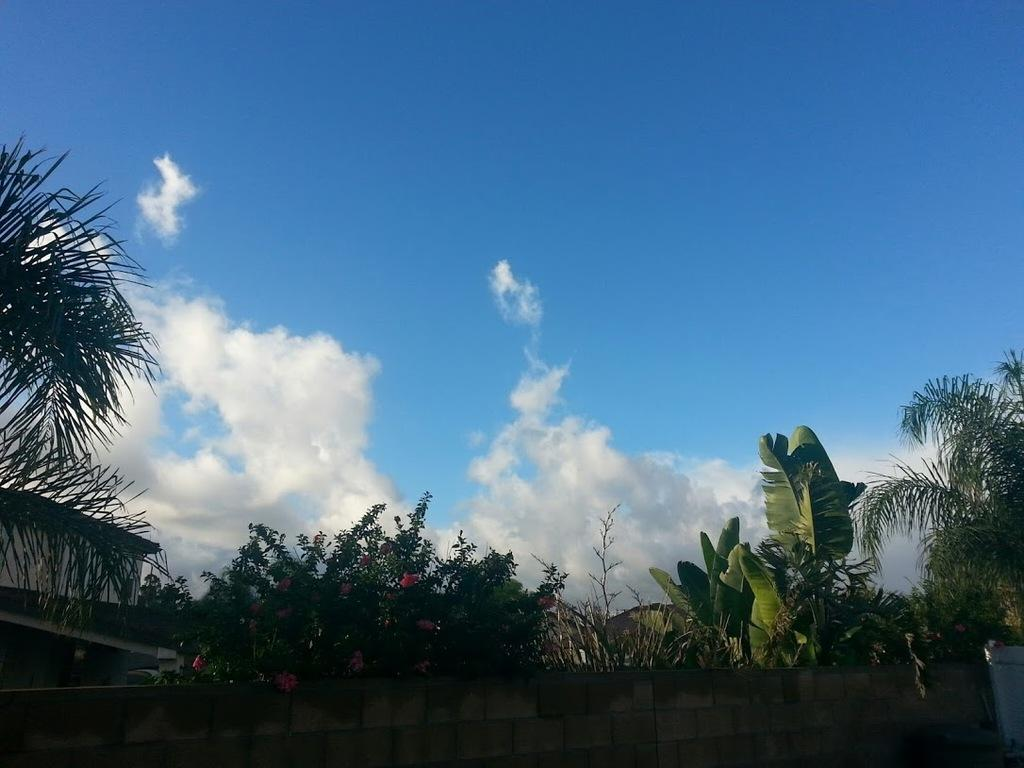What type of structure is visible in the image? There is a building in the image. What other natural elements can be seen in the image? There are trees in the image. How would you describe the sky in the image? The sky is blue and cloudy in the image. Where is the cannon located in the image? There is no cannon present in the image. How does the building turn in the image? Buildings do not turn; they are stationary structures. 